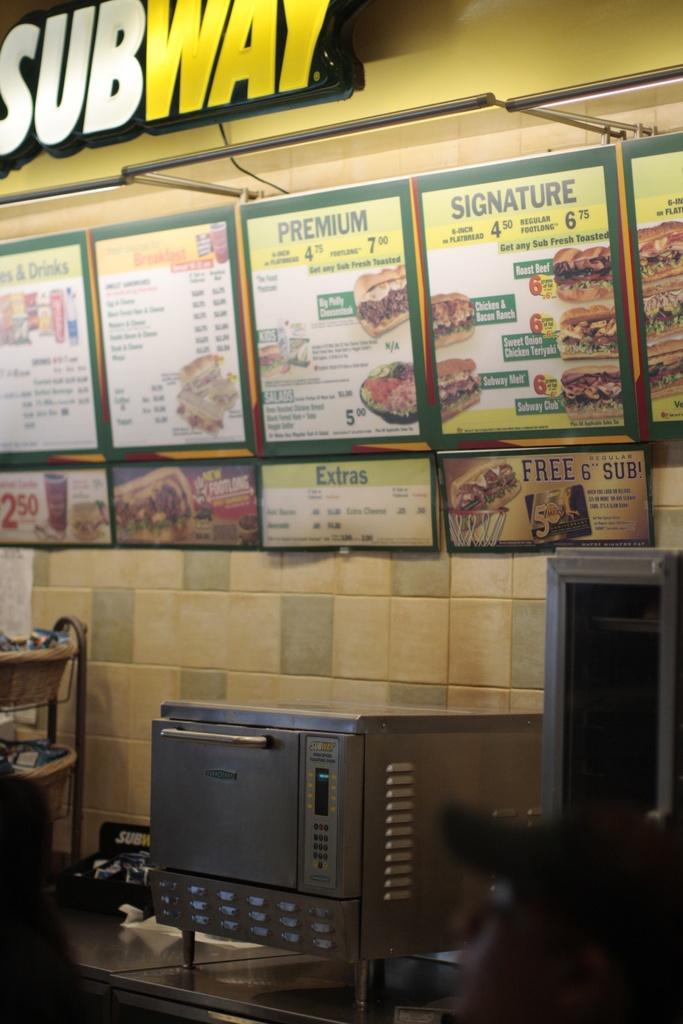What resurant is this?
Keep it short and to the point. Subway. 